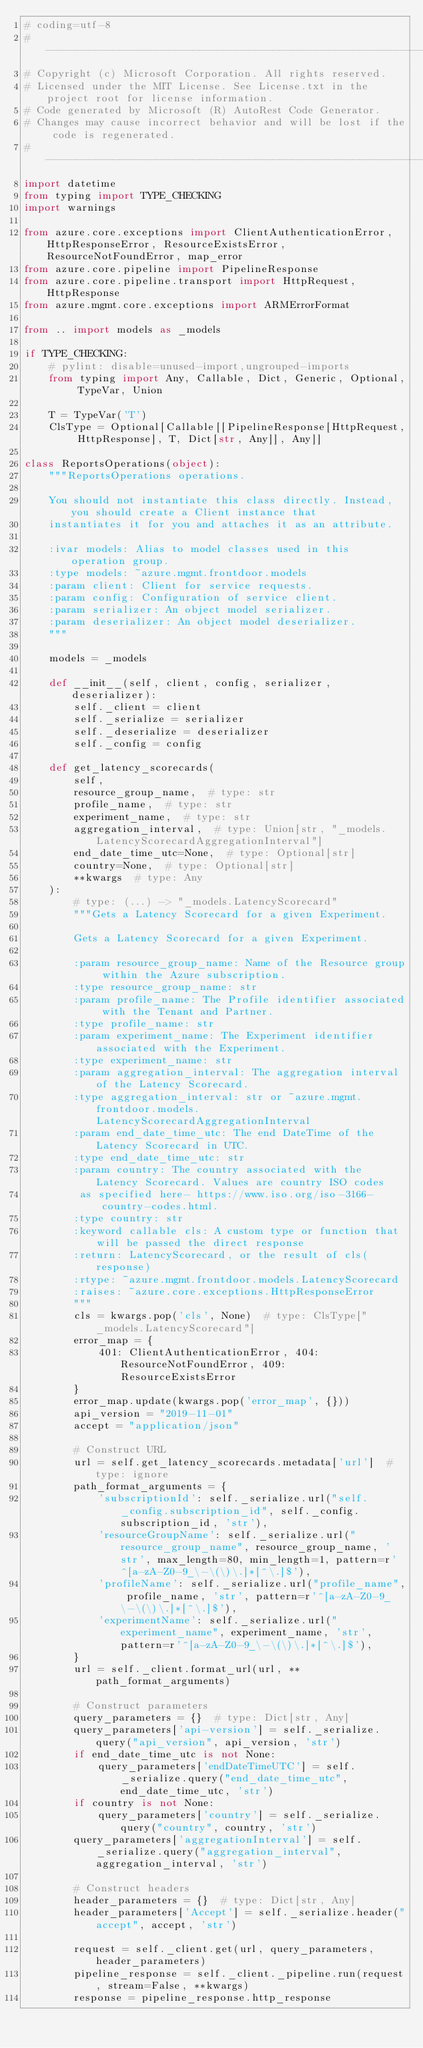Convert code to text. <code><loc_0><loc_0><loc_500><loc_500><_Python_># coding=utf-8
# --------------------------------------------------------------------------
# Copyright (c) Microsoft Corporation. All rights reserved.
# Licensed under the MIT License. See License.txt in the project root for license information.
# Code generated by Microsoft (R) AutoRest Code Generator.
# Changes may cause incorrect behavior and will be lost if the code is regenerated.
# --------------------------------------------------------------------------
import datetime
from typing import TYPE_CHECKING
import warnings

from azure.core.exceptions import ClientAuthenticationError, HttpResponseError, ResourceExistsError, ResourceNotFoundError, map_error
from azure.core.pipeline import PipelineResponse
from azure.core.pipeline.transport import HttpRequest, HttpResponse
from azure.mgmt.core.exceptions import ARMErrorFormat

from .. import models as _models

if TYPE_CHECKING:
    # pylint: disable=unused-import,ungrouped-imports
    from typing import Any, Callable, Dict, Generic, Optional, TypeVar, Union

    T = TypeVar('T')
    ClsType = Optional[Callable[[PipelineResponse[HttpRequest, HttpResponse], T, Dict[str, Any]], Any]]

class ReportsOperations(object):
    """ReportsOperations operations.

    You should not instantiate this class directly. Instead, you should create a Client instance that
    instantiates it for you and attaches it as an attribute.

    :ivar models: Alias to model classes used in this operation group.
    :type models: ~azure.mgmt.frontdoor.models
    :param client: Client for service requests.
    :param config: Configuration of service client.
    :param serializer: An object model serializer.
    :param deserializer: An object model deserializer.
    """

    models = _models

    def __init__(self, client, config, serializer, deserializer):
        self._client = client
        self._serialize = serializer
        self._deserialize = deserializer
        self._config = config

    def get_latency_scorecards(
        self,
        resource_group_name,  # type: str
        profile_name,  # type: str
        experiment_name,  # type: str
        aggregation_interval,  # type: Union[str, "_models.LatencyScorecardAggregationInterval"]
        end_date_time_utc=None,  # type: Optional[str]
        country=None,  # type: Optional[str]
        **kwargs  # type: Any
    ):
        # type: (...) -> "_models.LatencyScorecard"
        """Gets a Latency Scorecard for a given Experiment.

        Gets a Latency Scorecard for a given Experiment.

        :param resource_group_name: Name of the Resource group within the Azure subscription.
        :type resource_group_name: str
        :param profile_name: The Profile identifier associated with the Tenant and Partner.
        :type profile_name: str
        :param experiment_name: The Experiment identifier associated with the Experiment.
        :type experiment_name: str
        :param aggregation_interval: The aggregation interval of the Latency Scorecard.
        :type aggregation_interval: str or ~azure.mgmt.frontdoor.models.LatencyScorecardAggregationInterval
        :param end_date_time_utc: The end DateTime of the Latency Scorecard in UTC.
        :type end_date_time_utc: str
        :param country: The country associated with the Latency Scorecard. Values are country ISO codes
         as specified here- https://www.iso.org/iso-3166-country-codes.html.
        :type country: str
        :keyword callable cls: A custom type or function that will be passed the direct response
        :return: LatencyScorecard, or the result of cls(response)
        :rtype: ~azure.mgmt.frontdoor.models.LatencyScorecard
        :raises: ~azure.core.exceptions.HttpResponseError
        """
        cls = kwargs.pop('cls', None)  # type: ClsType["_models.LatencyScorecard"]
        error_map = {
            401: ClientAuthenticationError, 404: ResourceNotFoundError, 409: ResourceExistsError
        }
        error_map.update(kwargs.pop('error_map', {}))
        api_version = "2019-11-01"
        accept = "application/json"

        # Construct URL
        url = self.get_latency_scorecards.metadata['url']  # type: ignore
        path_format_arguments = {
            'subscriptionId': self._serialize.url("self._config.subscription_id", self._config.subscription_id, 'str'),
            'resourceGroupName': self._serialize.url("resource_group_name", resource_group_name, 'str', max_length=80, min_length=1, pattern=r'^[a-zA-Z0-9_\-\(\)\.]*[^\.]$'),
            'profileName': self._serialize.url("profile_name", profile_name, 'str', pattern=r'^[a-zA-Z0-9_\-\(\)\.]*[^\.]$'),
            'experimentName': self._serialize.url("experiment_name", experiment_name, 'str', pattern=r'^[a-zA-Z0-9_\-\(\)\.]*[^\.]$'),
        }
        url = self._client.format_url(url, **path_format_arguments)

        # Construct parameters
        query_parameters = {}  # type: Dict[str, Any]
        query_parameters['api-version'] = self._serialize.query("api_version", api_version, 'str')
        if end_date_time_utc is not None:
            query_parameters['endDateTimeUTC'] = self._serialize.query("end_date_time_utc", end_date_time_utc, 'str')
        if country is not None:
            query_parameters['country'] = self._serialize.query("country", country, 'str')
        query_parameters['aggregationInterval'] = self._serialize.query("aggregation_interval", aggregation_interval, 'str')

        # Construct headers
        header_parameters = {}  # type: Dict[str, Any]
        header_parameters['Accept'] = self._serialize.header("accept", accept, 'str')

        request = self._client.get(url, query_parameters, header_parameters)
        pipeline_response = self._client._pipeline.run(request, stream=False, **kwargs)
        response = pipeline_response.http_response
</code> 